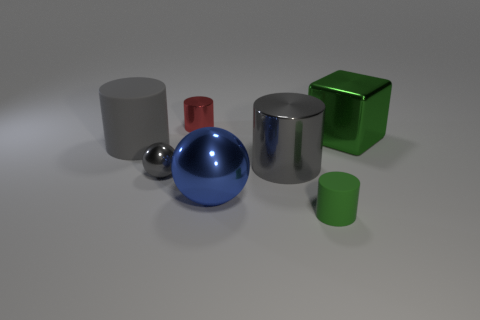What is the size of the ball that is the same color as the big rubber thing?
Your answer should be compact. Small. How many green things are either tiny metallic cylinders or big matte objects?
Your answer should be compact. 0. There is a cylinder that is both to the right of the blue object and behind the tiny green rubber cylinder; what size is it?
Your answer should be very brief. Large. Are there more big objects that are behind the large rubber object than tiny shiny things?
Provide a succinct answer. No. How many spheres are either tiny gray shiny objects or blue metallic things?
Your response must be concise. 2. What shape is the small object that is on the right side of the tiny gray sphere and in front of the tiny metal cylinder?
Keep it short and to the point. Cylinder. Are there an equal number of things behind the tiny green thing and tiny gray metal balls behind the big gray rubber cylinder?
Keep it short and to the point. No. What number of objects are matte cylinders or blue spheres?
Provide a succinct answer. 3. The metal sphere that is the same size as the red metal object is what color?
Provide a short and direct response. Gray. What number of things are shiny cylinders that are in front of the big green object or shiny cylinders that are in front of the cube?
Your response must be concise. 1. 